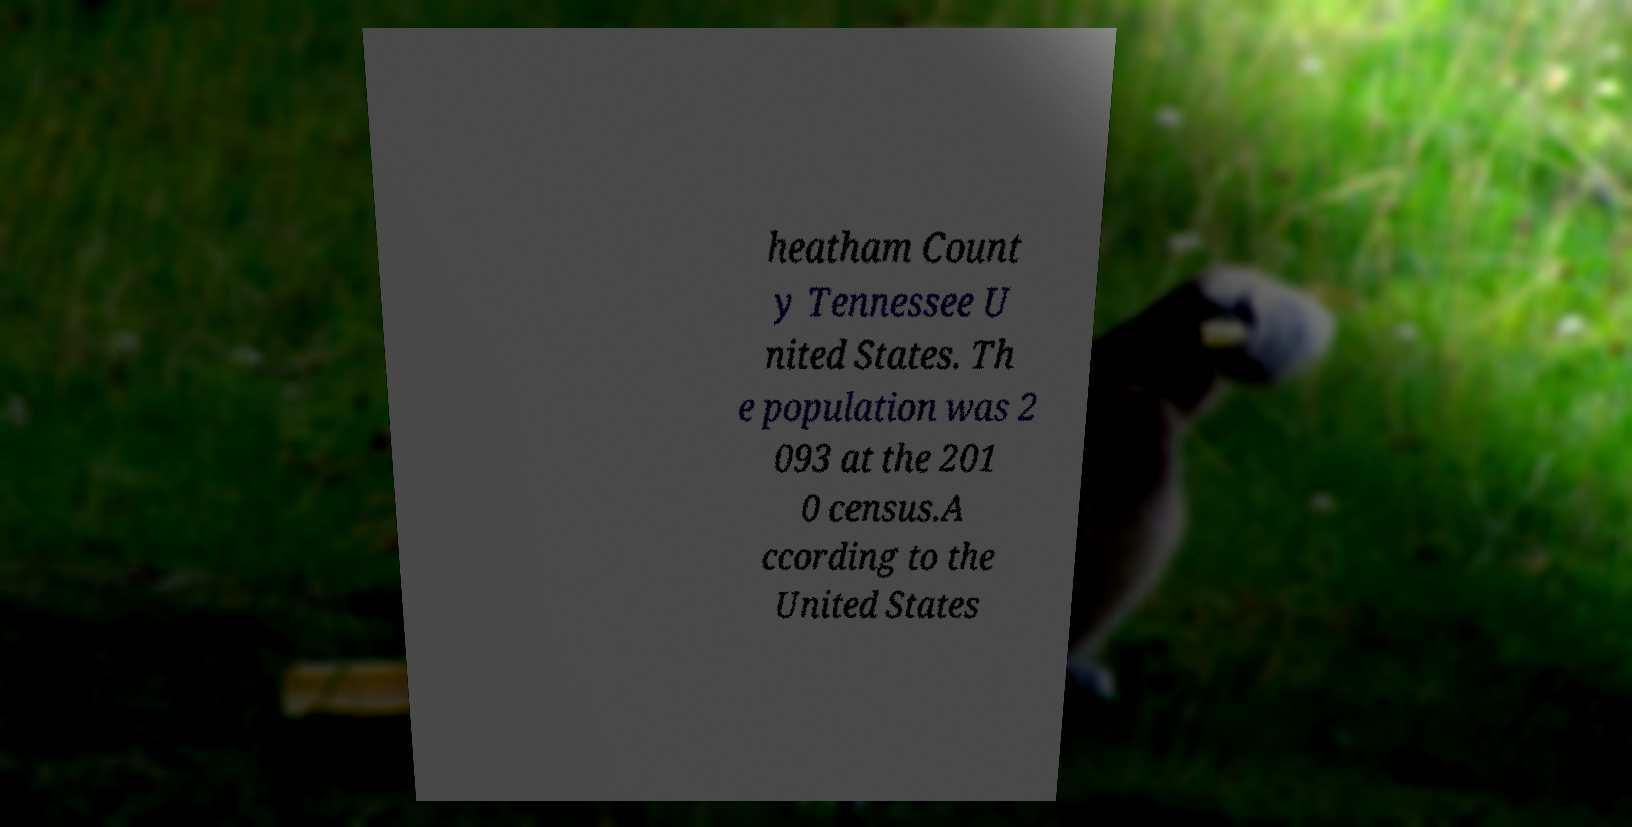Could you assist in decoding the text presented in this image and type it out clearly? heatham Count y Tennessee U nited States. Th e population was 2 093 at the 201 0 census.A ccording to the United States 